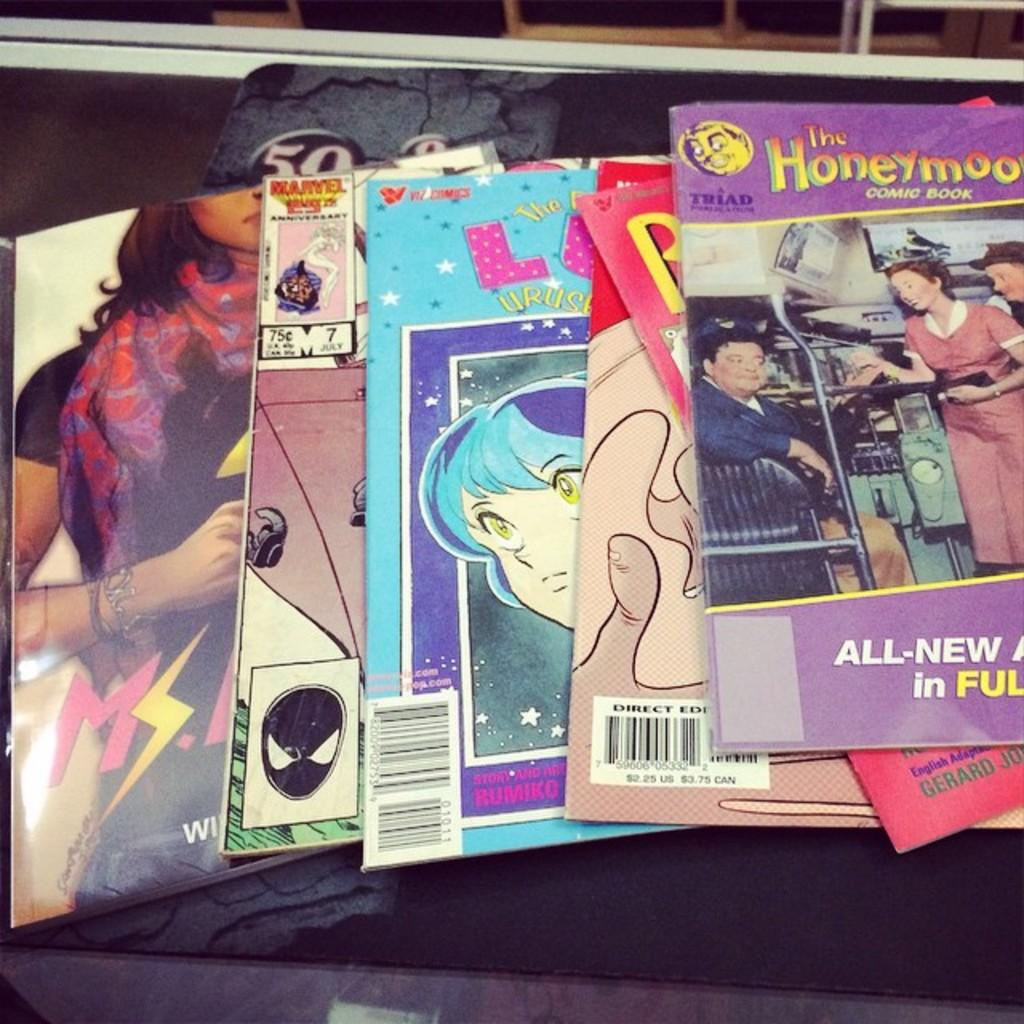Provide a one-sentence caption for the provided image. A collection of colorful booklets with The Honeymooners on top. 